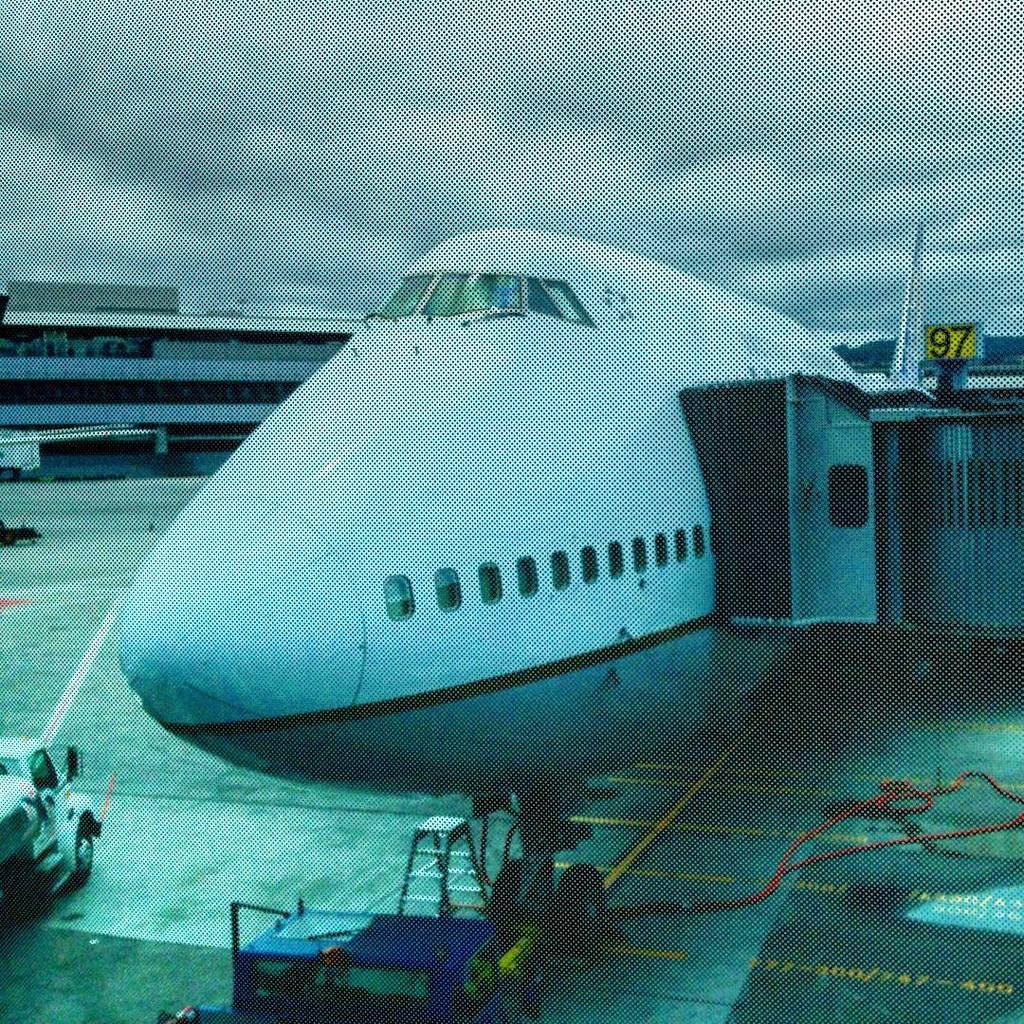What number gate is this?
Give a very brief answer. 97. What number is written in red on the yellow sign?
Keep it short and to the point. 97. 